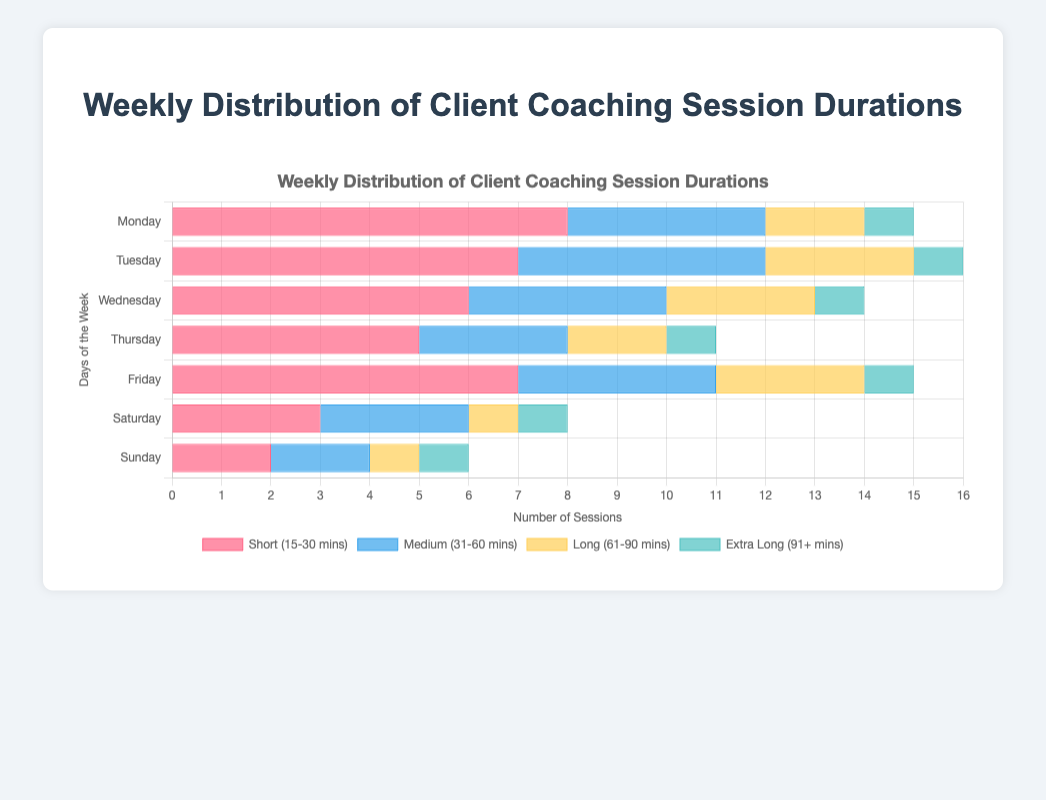Which day has the highest number of Short (15-30 mins) sessions? By examining the bars representing Short session durations, the tallest bar indicates the highest number. The bar for Monday is the tallest with 8 sessions.
Answer: Monday What's the total number of sessions held on Tuesday? Sum the sessions for each duration type on Tuesday: Short (7) + Medium (5) + Long (3) + Extra Long (1) = 16.
Answer: 16 Which session duration has the least number of sessions on Sunday? Look at the bars corresponding to Sunday for all duration types. The shortest bar is for Medium (31-60 mins) with 2 sessions.
Answer: Medium (31-60 mins) How many more Short sessions are there on Monday compared to Sunday? Subtract the number of Short sessions on Sunday (2) from the number on Monday (8): 8 - 2 = 6.
Answer: 6 What is the average number of Medium (31-60 mins) sessions per day? Divide the total Medium sessions (25) by 7 days: 25 / 7 ≈ 3.57.
Answer: 3.57 Which day has the most evenly distributed session durations across all types? Examine which day has bars of approximately equal lengths across all session types. Friday has a fairly even distribution with 7 (Short), 4 (Medium), 3 (Long), and 1 (Extra Long).
Answer: Friday Compare the total number of Long (61-90 mins) and Extra Long (91+ mins) sessions. Which is greater? Calculate the totals: Long (15) and Extra Long (7). Long has more sessions than Extra Long.
Answer: Long (61-90 mins) What's the combined number of Short and Medium sessions on Wednesday? Add the sessions for both types on Wednesday: Short (6) + Medium (4) = 10.
Answer: 10 How does the number of sessions on Saturday for Long and Extra Long durations compare visually? The bar for Long sessions on Saturday is slightly taller than the bar for Extra Long sessions, indicating there is 1 more Long session (1 compared to 1 for Extra Long).
Answer: Long sessions are greater What is the overall trend for Short sessions throughout the week? Observing the bar lengths for Short sessions from Monday to Sunday, the trend shows a decrease starting high on Monday (8), declining towards the weekend (3 on Saturday, 2 on Sunday).
Answer: Decreasing trend 